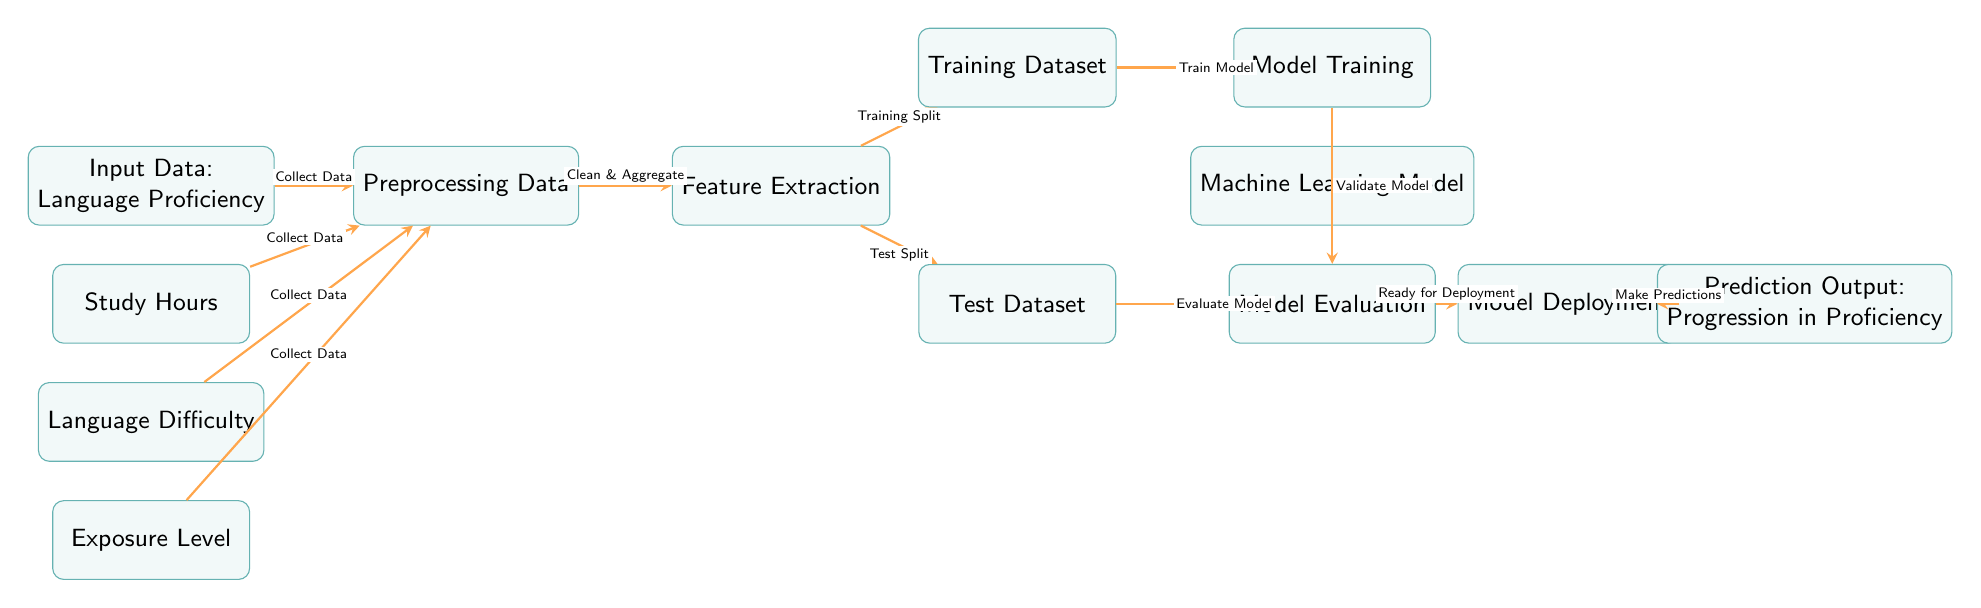What is the first node in the diagram? The first node in the diagram is "Input Data: Language Proficiency." This is identified as the starting point of the flow, located at the top left of the diagram.
Answer: Input Data: Language Proficiency How many factors are considered in the model? The model accounts for four factors: Study Hours, Language Difficulty, and Exposure Level. These factors are represented by distinct nodes beneath the input data node.
Answer: Three What is the role of the "Preprocessing Data" node? The "Preprocessing Data" node cleans and aggregates the collected data from the input nodes. It follows immediately after the input data node, indicating its function as a preparatory step for the next stage.
Answer: Clean & Aggregate What does the "Model Deployment" node lead to? The "Model Deployment" node leads to the "Prediction Output: Progression in Proficiency" node, which indicates that once the model is deployed, it generates predictions regarding language proficiency progression.
Answer: Prediction Output: Progression in Proficiency What is the relationship between the "Training Dataset" and "Test Dataset"? The "Training Dataset" and "Test Dataset" nodes are both derived from the "Feature Extraction" node, indicating they are subsets of the preprocessed data that serve different purposes in model training and evaluation.
Answer: Derived subsets How many arrows are used to connect the "Model Training" and "Model Evaluation" nodes? There is one arrow that connects the "Model Training" node to the "Model Evaluation" node, indicating the sequential flow of operations from training to evaluation of the machine learning model.
Answer: One What happens after the "Model Evaluation" process? After the "Model Evaluation" process, the model reaches the "Ready for Deployment" state, indicating that it has been evaluated and is now prepared for use in practical applications.
Answer: Ready for Deployment In which order do the model training and model evaluation processes occur? The "Model Training" process occurs before the "Model Evaluation" process, as the training must be completed to assess the model's performance effectively. This order is reflected in the layout of the diagram.
Answer: Model Training before Model Evaluation What is the final output of the diagram? The final output of the diagram is "Prediction Output: Progression in Proficiency," which is produced after the model has been deployed and is making predictions based on the trained data.
Answer: Prediction Output: Progression in Proficiency 